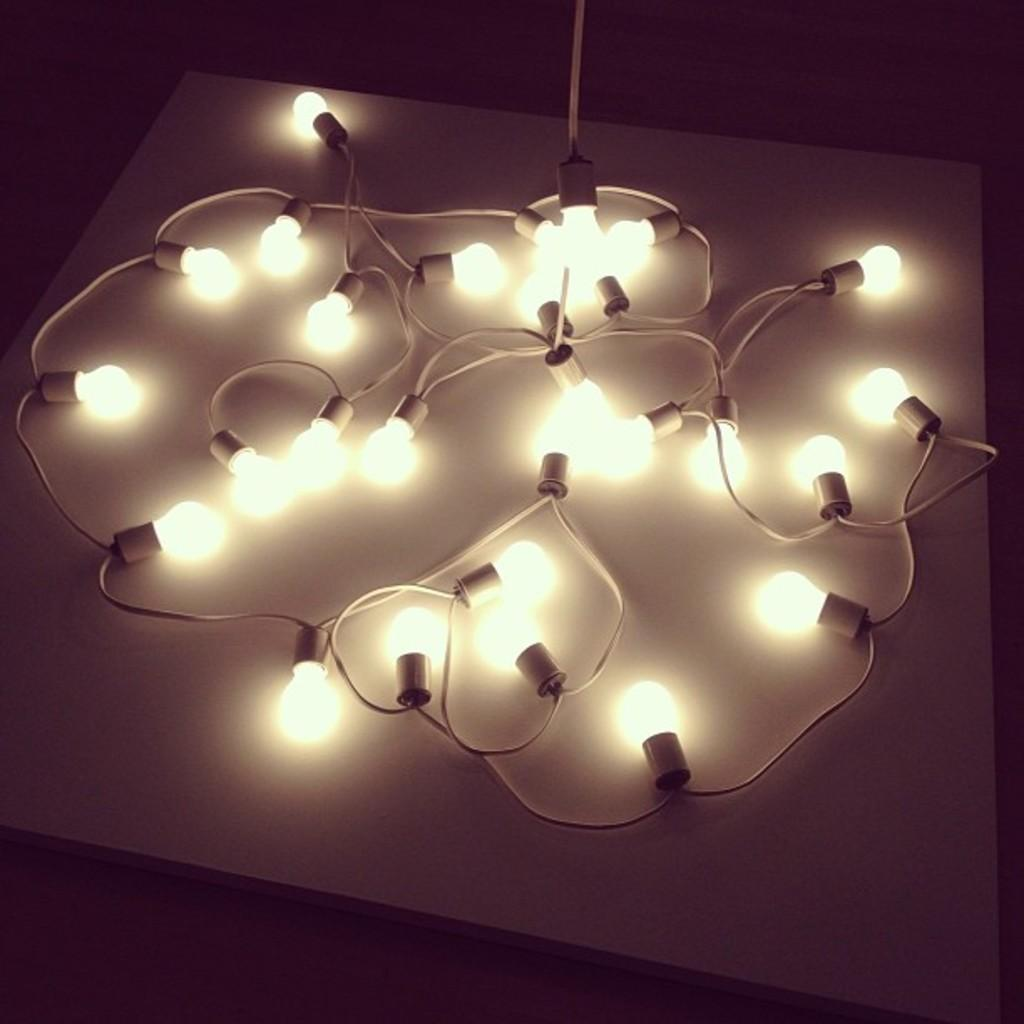What is the overall lighting condition of the image? The image is dark. What objects are present in the image that might provide light? There are light bulbs in the image. How are the light bulbs connected to a power source? The light bulbs are accompanied by cables in the image. What is the color of the surface on which the light bulbs and cables are placed? The light bulbs and cables are on a white surface. Can you see any mice running around on the wall in the image? There are no mice or walls present in the image; it features light bulbs and cables on a white surface. How many nails are used to attach the light bulbs to the wall in the image? There are no nails or walls present in the image; it features light bulbs and cables on a white surface. 